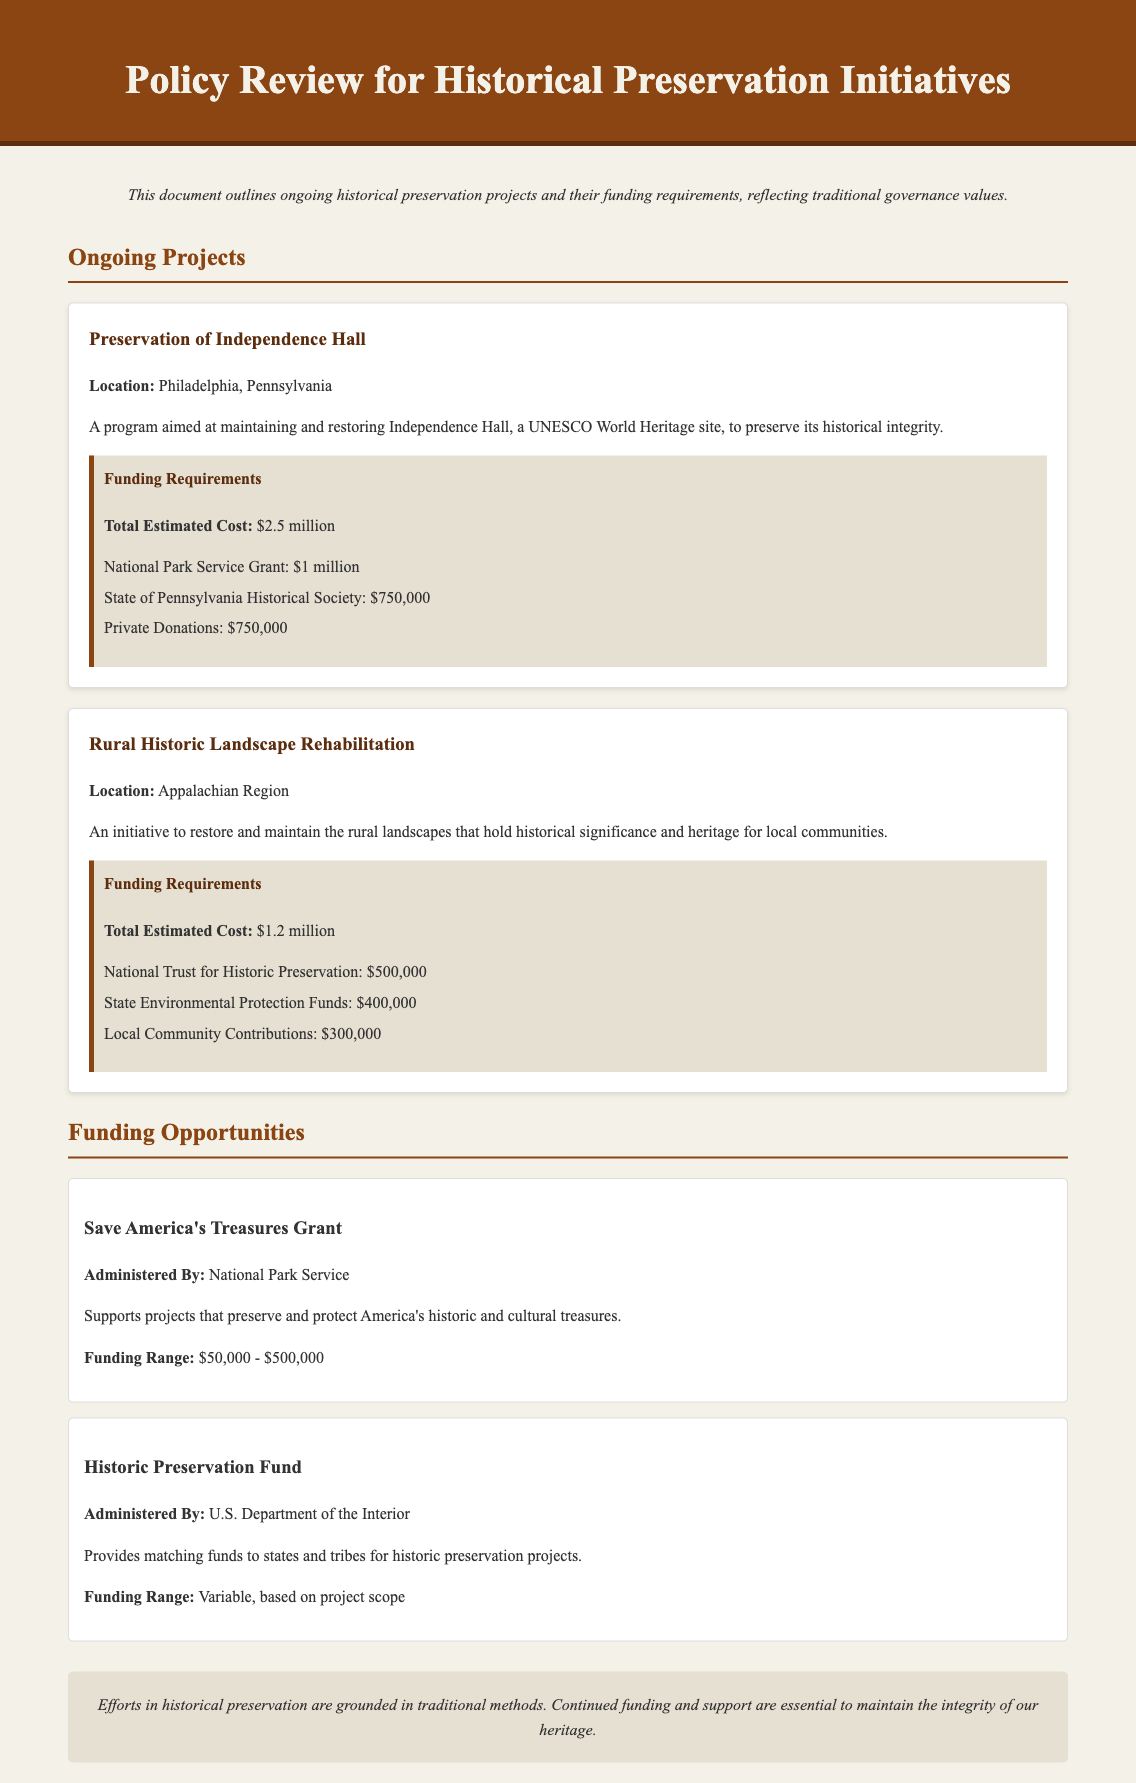What is the project aimed at preserving Independence Hall? The project mentioned specifically is focused on maintaining and restoring Independence Hall, which is a UNESCO World Heritage site.
Answer: Preservation of Independence Hall What is the total estimated cost for the Rural Historic Landscape Rehabilitation project? The document states that the total estimated cost for this project is $1.2 million.
Answer: $1.2 million How much funding is provided by the National Park Service for the Preservation of Independence Hall? The document indicates that the National Park Service will provide $1 million for this particular project.
Answer: $1 million Who administers the Save America's Treasures Grant? The document states that this grant is administered by the National Park Service.
Answer: National Park Service What are the local community contributions for the Rural Historic Landscape Rehabilitation project? The local community contributions for this project are specified as $300,000 in the document.
Answer: $300,000 What is the range of funding offered by the Historic Preservation Fund? The funding range for the Historic Preservation Fund is variable and depends on the project scope, as mentioned in the document.
Answer: Variable, based on project scope Which region is targeted for the Rural Historic Landscape Rehabilitation initiative? According to the document, the initiative targets the Appalachian Region for its historical significance.
Answer: Appalachian Region What is the total estimated cost for preserving Independence Hall? The document specifies that the total estimated cost for preserving Independence Hall is $2.5 million.
Answer: $2.5 million What type of initiative is mentioned for maintaining historical landscapes? The document describes the initiative as Rural Historic Landscape Rehabilitation, focusing on restoration and maintenance.
Answer: Rural Historic Landscape Rehabilitation 